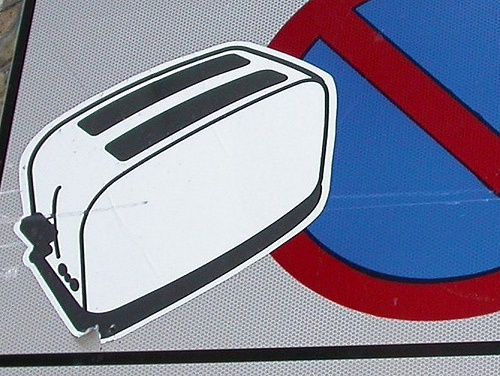Describe the objects in this image and their specific colors. I can see a toaster in darkgray, white, black, and purple tones in this image. 